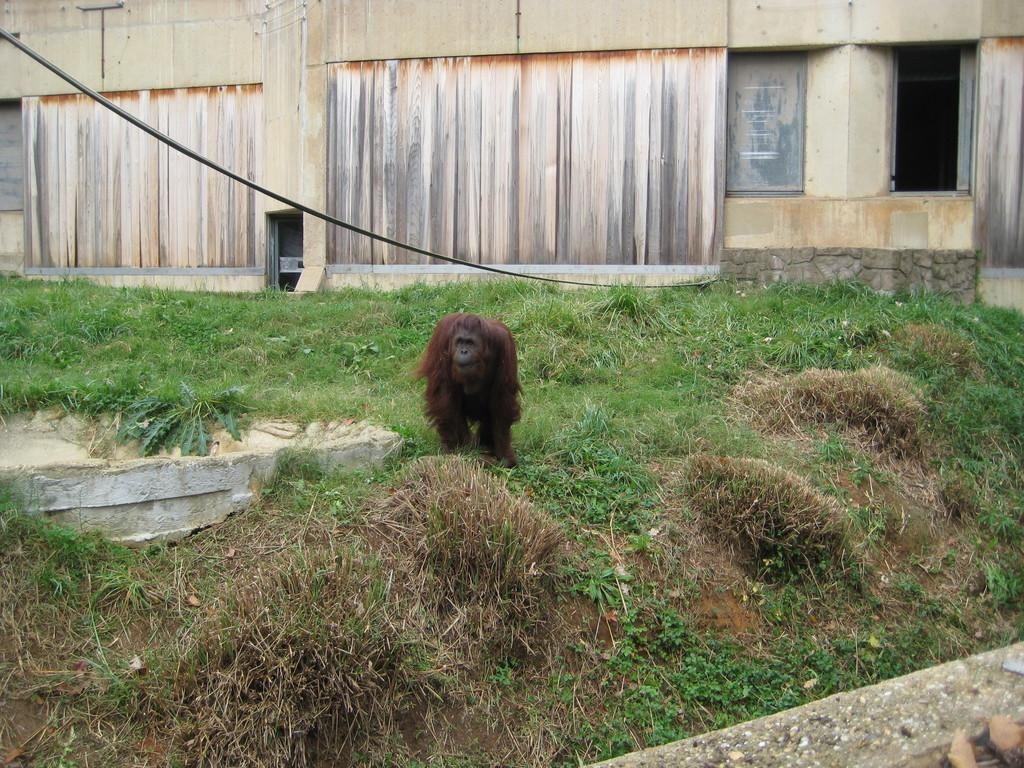What type of animal is in the image? The specific type of animal is not mentioned, but it is an animal that is on the grass. Can you describe the setting where the animal is located? The animal is on the grass, and there is a building with windows and a door in the background of the image. What can be seen in the background of the image? In addition to the building, there is a wire visible in the background. When was the image taken? The image was taken during the day. What type of fruit is hanging from the wire in the image? There is no fruit hanging from the wire in the image; only the wire is visible in the background. 